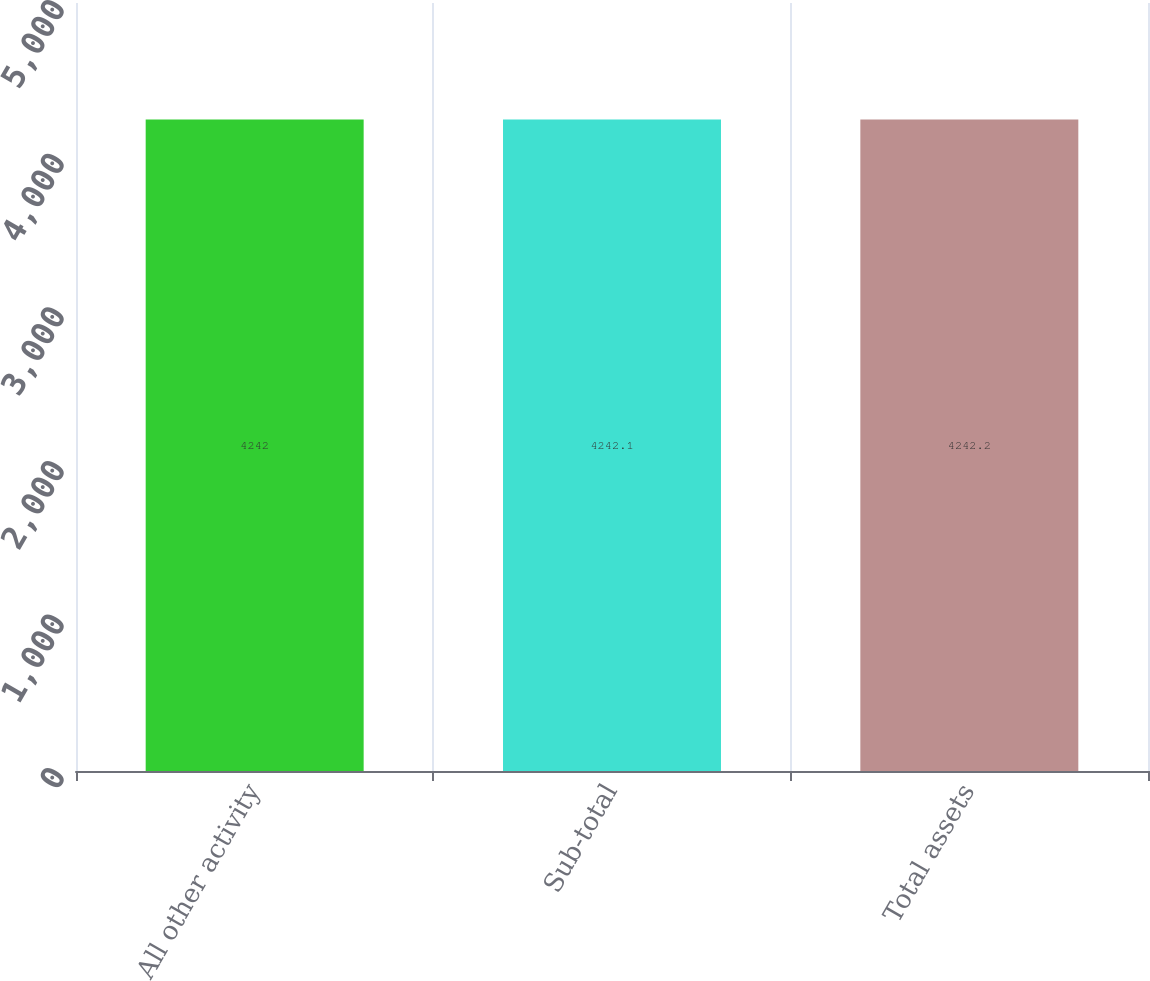<chart> <loc_0><loc_0><loc_500><loc_500><bar_chart><fcel>All other activity<fcel>Sub-total<fcel>Total assets<nl><fcel>4242<fcel>4242.1<fcel>4242.2<nl></chart> 